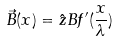<formula> <loc_0><loc_0><loc_500><loc_500>\vec { B } ( x ) = \hat { z } B f ^ { \prime } ( \frac { x } { \lambda } )</formula> 